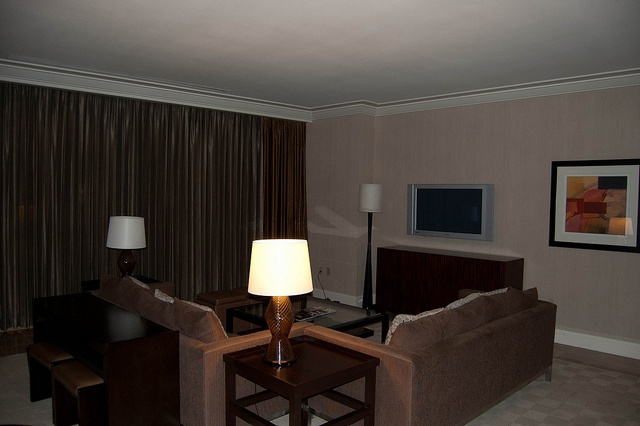Describe the objects in this image and their specific colors. I can see couch in gray, black, and maroon tones, couch in gray and black tones, couch in gray, black, and maroon tones, tv in gray and black tones, and dining table in gray and black tones in this image. 